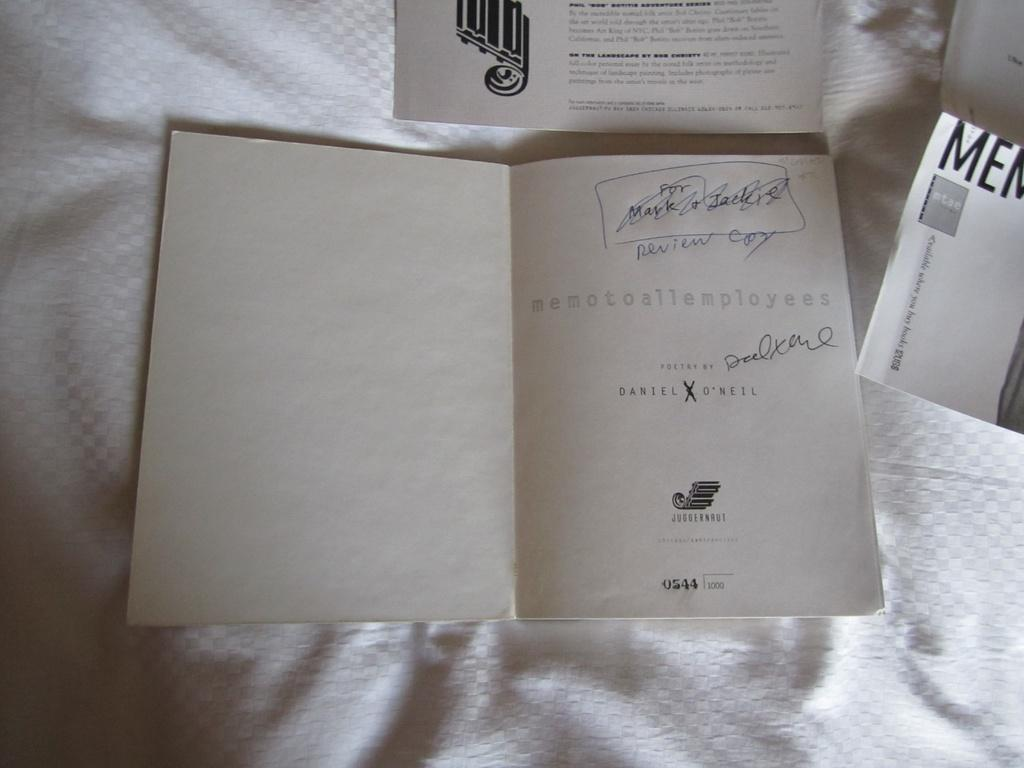<image>
Provide a brief description of the given image. A book is opened to the first page which says it is poetry by Daniel O'neil. 